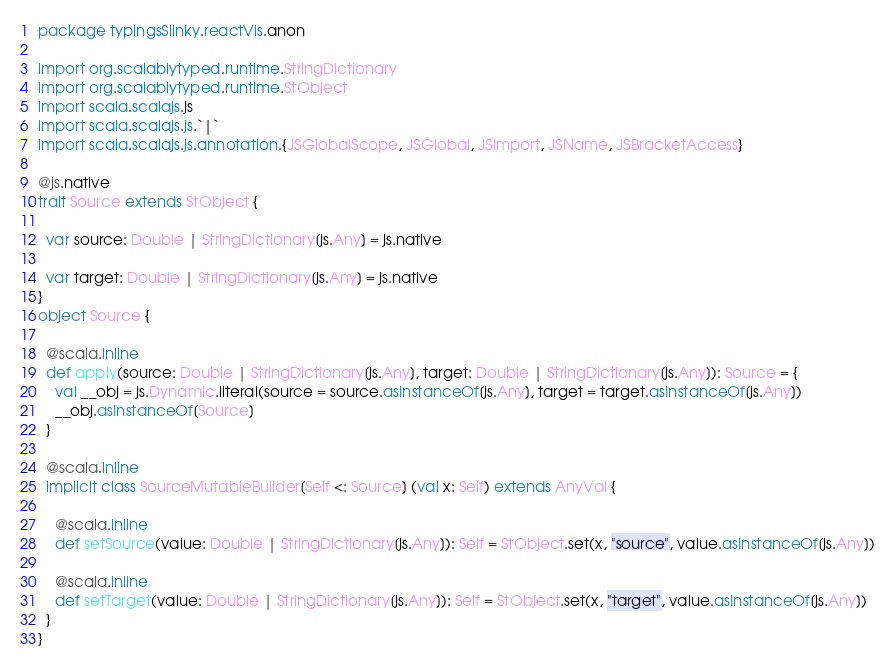Convert code to text. <code><loc_0><loc_0><loc_500><loc_500><_Scala_>package typingsSlinky.reactVis.anon

import org.scalablytyped.runtime.StringDictionary
import org.scalablytyped.runtime.StObject
import scala.scalajs.js
import scala.scalajs.js.`|`
import scala.scalajs.js.annotation.{JSGlobalScope, JSGlobal, JSImport, JSName, JSBracketAccess}

@js.native
trait Source extends StObject {
  
  var source: Double | StringDictionary[js.Any] = js.native
  
  var target: Double | StringDictionary[js.Any] = js.native
}
object Source {
  
  @scala.inline
  def apply(source: Double | StringDictionary[js.Any], target: Double | StringDictionary[js.Any]): Source = {
    val __obj = js.Dynamic.literal(source = source.asInstanceOf[js.Any], target = target.asInstanceOf[js.Any])
    __obj.asInstanceOf[Source]
  }
  
  @scala.inline
  implicit class SourceMutableBuilder[Self <: Source] (val x: Self) extends AnyVal {
    
    @scala.inline
    def setSource(value: Double | StringDictionary[js.Any]): Self = StObject.set(x, "source", value.asInstanceOf[js.Any])
    
    @scala.inline
    def setTarget(value: Double | StringDictionary[js.Any]): Self = StObject.set(x, "target", value.asInstanceOf[js.Any])
  }
}
</code> 